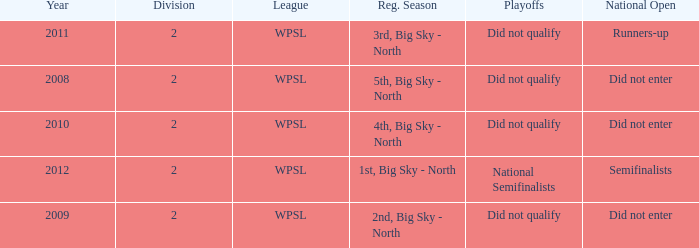What league was involved in 2008? WPSL. 